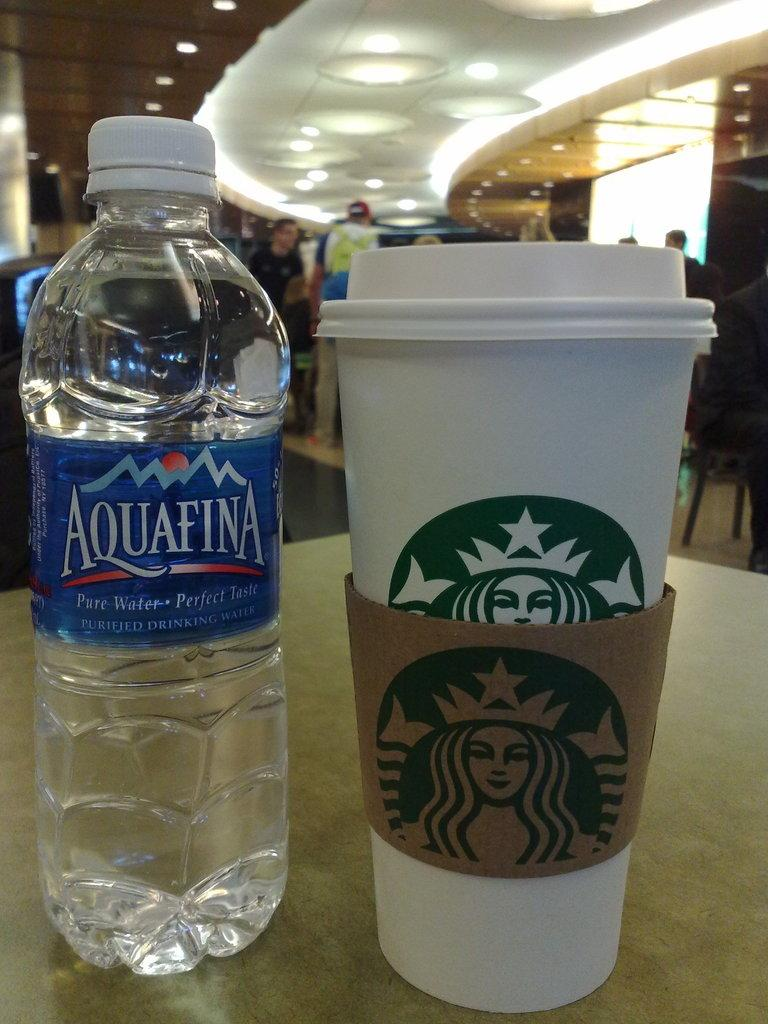<image>
Provide a brief description of the given image. the word Aquafina that is on a bottle 